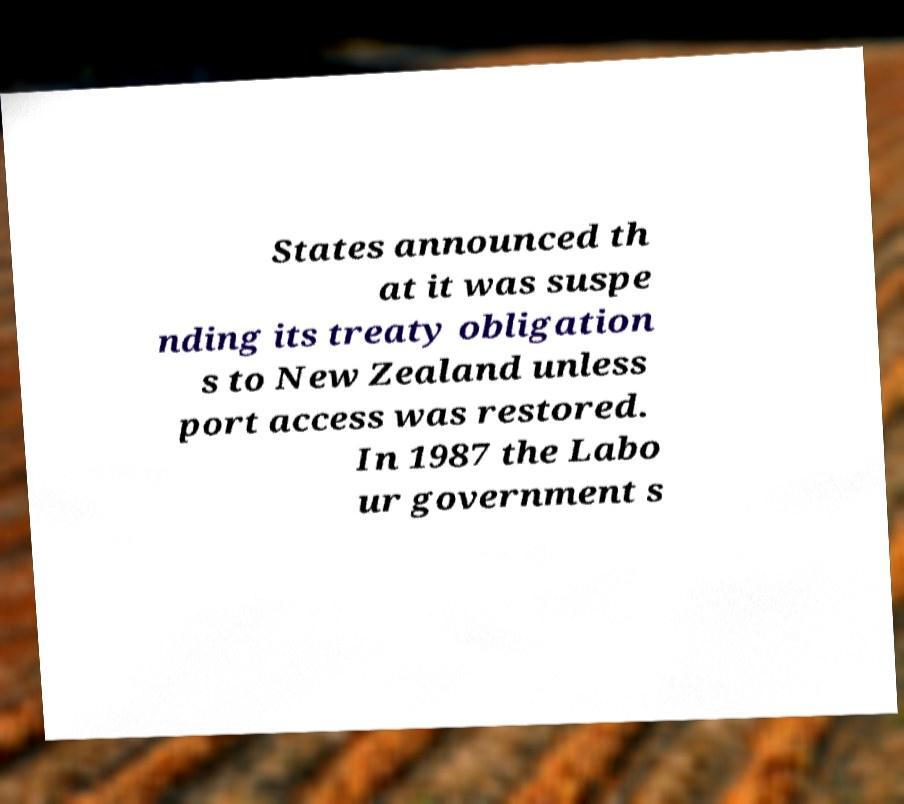What messages or text are displayed in this image? I need them in a readable, typed format. States announced th at it was suspe nding its treaty obligation s to New Zealand unless port access was restored. In 1987 the Labo ur government s 